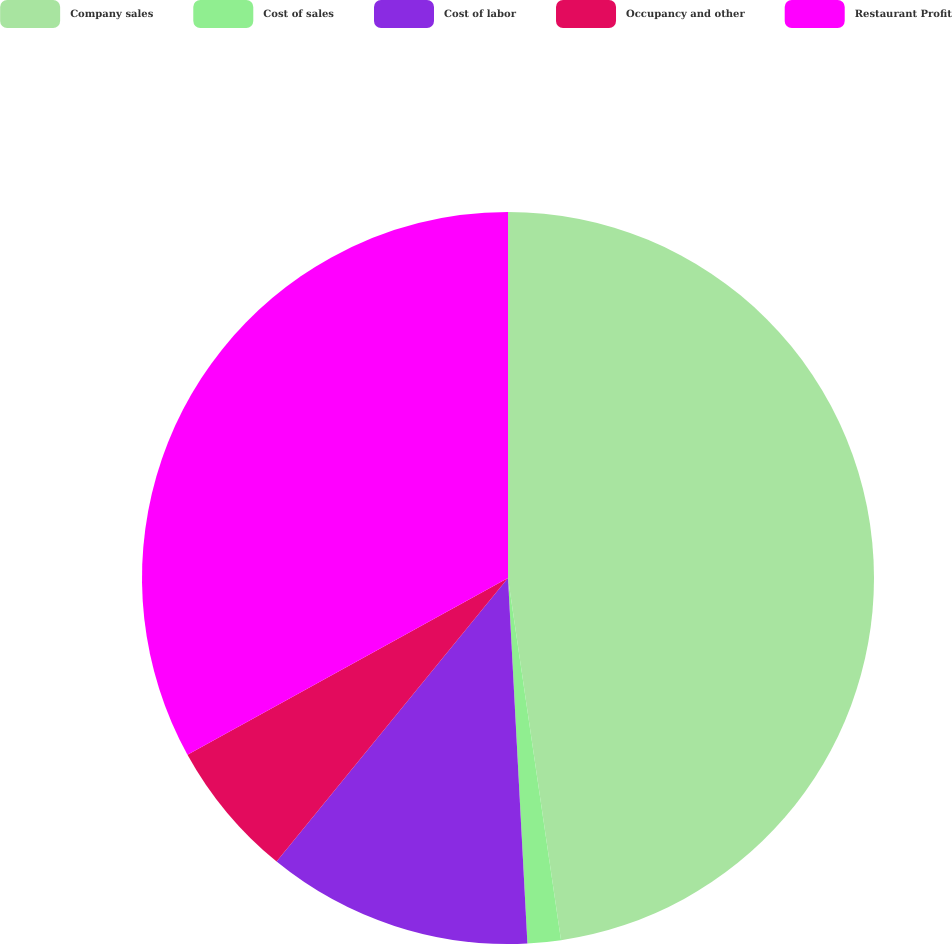Convert chart to OTSL. <chart><loc_0><loc_0><loc_500><loc_500><pie_chart><fcel>Company sales<fcel>Cost of sales<fcel>Cost of labor<fcel>Occupancy and other<fcel>Restaurant Profit<nl><fcel>47.69%<fcel>1.47%<fcel>11.74%<fcel>6.09%<fcel>33.02%<nl></chart> 